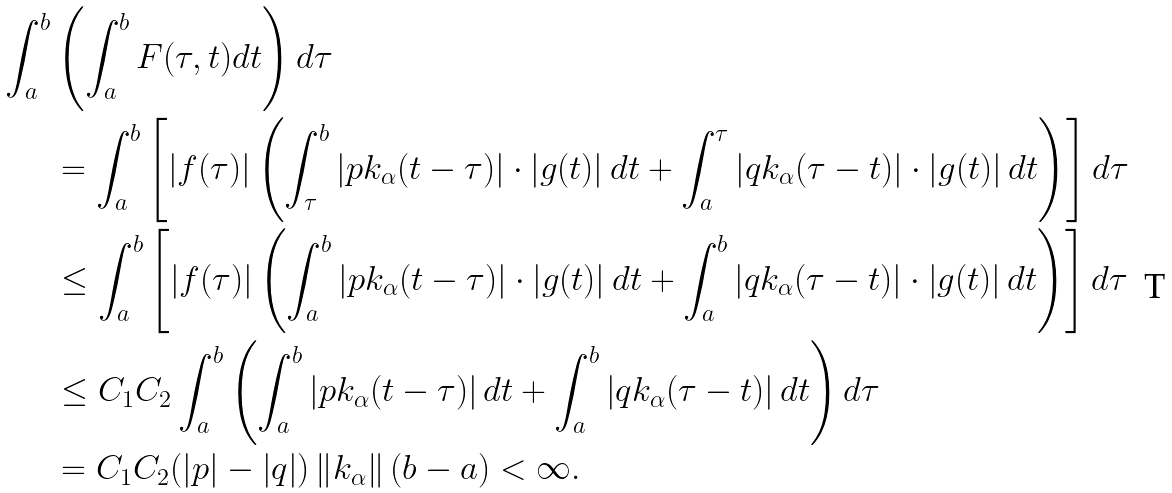<formula> <loc_0><loc_0><loc_500><loc_500>\int _ { a } ^ { b } & \left ( \int _ { a } ^ { b } F ( \tau , t ) d t \right ) d \tau \\ & = \int _ { a } ^ { b } \left [ \left | f ( \tau ) \right | \left ( \int _ { \tau } ^ { b } \left | p k _ { \alpha } ( t - \tau ) \right | \cdot \left | g ( t ) \right | d t + \int _ { a } ^ { \tau } \left | q k _ { \alpha } ( \tau - t ) \right | \cdot \left | g ( t ) \right | d t \right ) \right ] d \tau \\ & \leq \int _ { a } ^ { b } \left [ \left | f ( \tau ) \right | \left ( \int _ { a } ^ { b } \left | p k _ { \alpha } ( t - \tau ) \right | \cdot \left | g ( t ) \right | d t + \int _ { a } ^ { b } \left | q k _ { \alpha } ( \tau - t ) \right | \cdot \left | g ( t ) \right | d t \right ) \right ] d \tau \\ & \leq C _ { 1 } C _ { 2 } \int _ { a } ^ { b } \left ( \int _ { a } ^ { b } \left | p k _ { \alpha } ( t - \tau ) \right | d t + \int _ { a } ^ { b } \left | q k _ { \alpha } ( \tau - t ) \right | d t \right ) d \tau \\ & = C _ { 1 } C _ { 2 } ( \left | p \right | - \left | q \right | ) \left \| k _ { \alpha } \right \| ( b - a ) < \infty .</formula> 